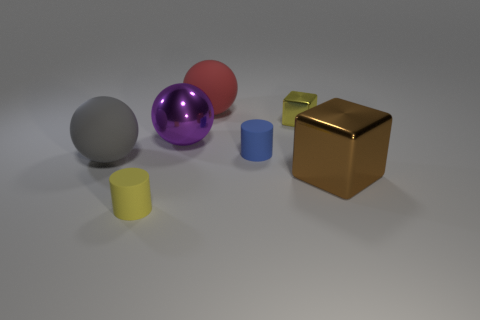What number of other objects have the same size as the yellow metallic thing?
Keep it short and to the point. 2. Are the purple sphere that is in front of the red ball and the yellow object to the right of the big metal ball made of the same material?
Ensure brevity in your answer.  Yes. What is the material of the yellow thing behind the big object that is right of the blue thing?
Give a very brief answer. Metal. There is a tiny yellow object that is behind the small yellow rubber cylinder; what is its material?
Make the answer very short. Metal. What number of other small matte objects are the same shape as the tiny blue rubber thing?
Offer a terse response. 1. What material is the large gray thing in front of the big object behind the metal block that is behind the big shiny cube?
Your response must be concise. Rubber. There is a gray sphere; are there any large purple balls right of it?
Offer a terse response. Yes. The gray object that is the same size as the red matte sphere is what shape?
Provide a succinct answer. Sphere. Do the tiny yellow block and the big cube have the same material?
Offer a terse response. Yes. How many metal objects are either big brown objects or small red things?
Provide a succinct answer. 1. 